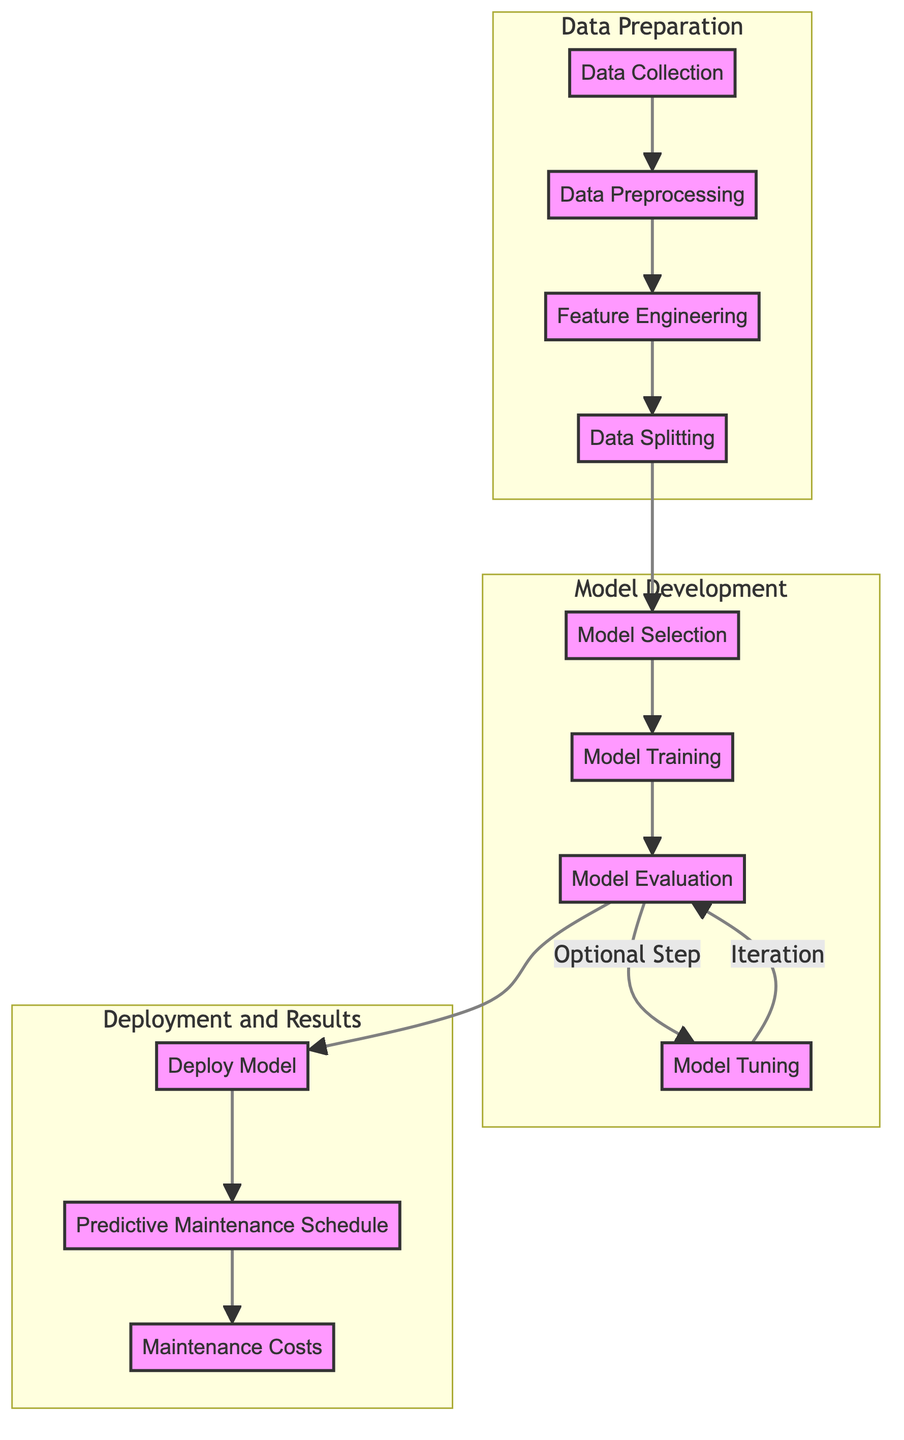What is the first step in the diagram? The first step, indicated by the starting node A, is "Data Collection."
Answer: Data Collection How many main subgraphs are there in the diagram? The diagram includes three main subgraphs: Data Preparation, Model Development, and Deployment and Results.
Answer: Three Which node comes after "Model Evaluation"? Following "Model Evaluation" (node G), the diagram indicates that the next step is "Deploy Model" (node I).
Answer: Deploy Model In which subgraph is "Feature Engineering" located? "Feature Engineering" is located in the Data Preparation subgraph, as it is one of the initial steps in preparing the data.
Answer: Data Preparation What happens after "Model Tuning"? After "Model Tuning" (node H), the diagram shows an arrow returning to "Model Evaluation" (node G), indicating an iterative process.
Answer: Model Evaluation What is the relationship between "Predictive Maintenance Schedule" and "Maintenance Costs"? The relationship shows that "Predictive Maintenance Schedule" (node J) leads to "Maintenance Costs" (node K), indicating that the schedule informs the costs associated with maintenance.
Answer: Leads to Which node requires optional iteration in the process? The node "Model Evaluation" (node G) requires optional iteration that can involve the "Model Tuning" (node H) step.
Answer: Model Evaluation What is the last node in the flowchart? The last node in the flowchart is "Maintenance Costs," representing the output of the predictive maintenance schedule process.
Answer: Maintenance Costs How many steps are in the Model Development subgraph? The Model Development subgraph contains four steps: "Model Selection," "Model Training," "Model Evaluation," and "Model Tuning."
Answer: Four 